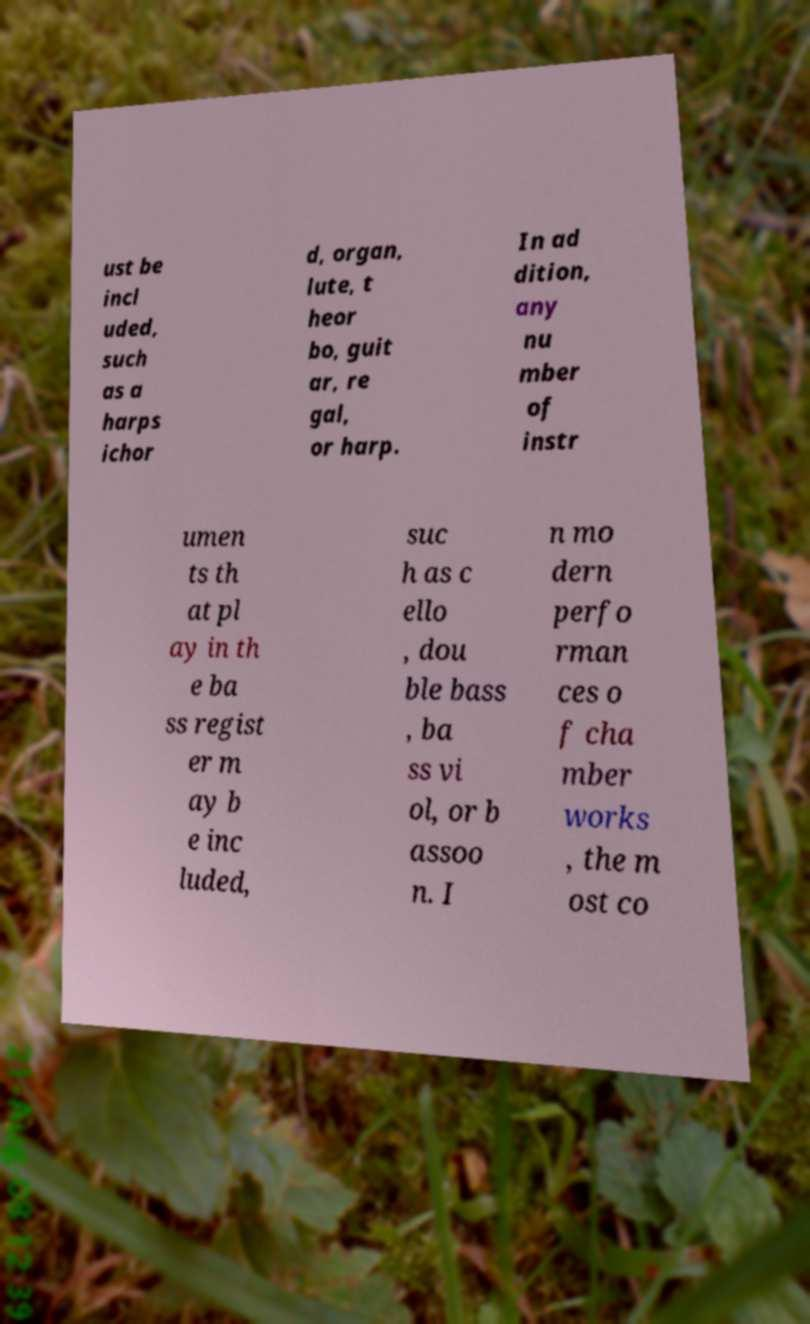Could you assist in decoding the text presented in this image and type it out clearly? ust be incl uded, such as a harps ichor d, organ, lute, t heor bo, guit ar, re gal, or harp. In ad dition, any nu mber of instr umen ts th at pl ay in th e ba ss regist er m ay b e inc luded, suc h as c ello , dou ble bass , ba ss vi ol, or b assoo n. I n mo dern perfo rman ces o f cha mber works , the m ost co 